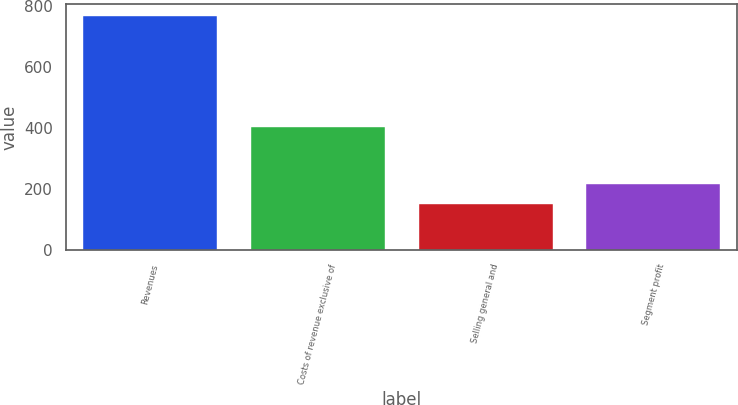Convert chart to OTSL. <chart><loc_0><loc_0><loc_500><loc_500><bar_chart><fcel>Revenues<fcel>Costs of revenue exclusive of<fcel>Selling general and<fcel>Segment profit<nl><fcel>766<fcel>402<fcel>149<fcel>215<nl></chart> 